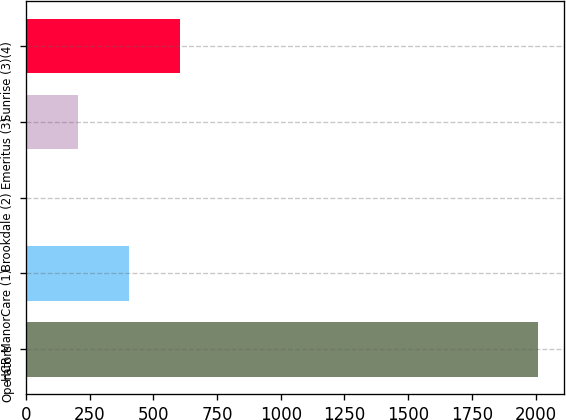Convert chart to OTSL. <chart><loc_0><loc_0><loc_500><loc_500><bar_chart><fcel>Operators<fcel>HCR ManorCare (1)<fcel>Brookdale (2)<fcel>Emeritus (3)<fcel>Sunrise (3)(4)<nl><fcel>2010<fcel>406<fcel>5<fcel>205.5<fcel>606.5<nl></chart> 